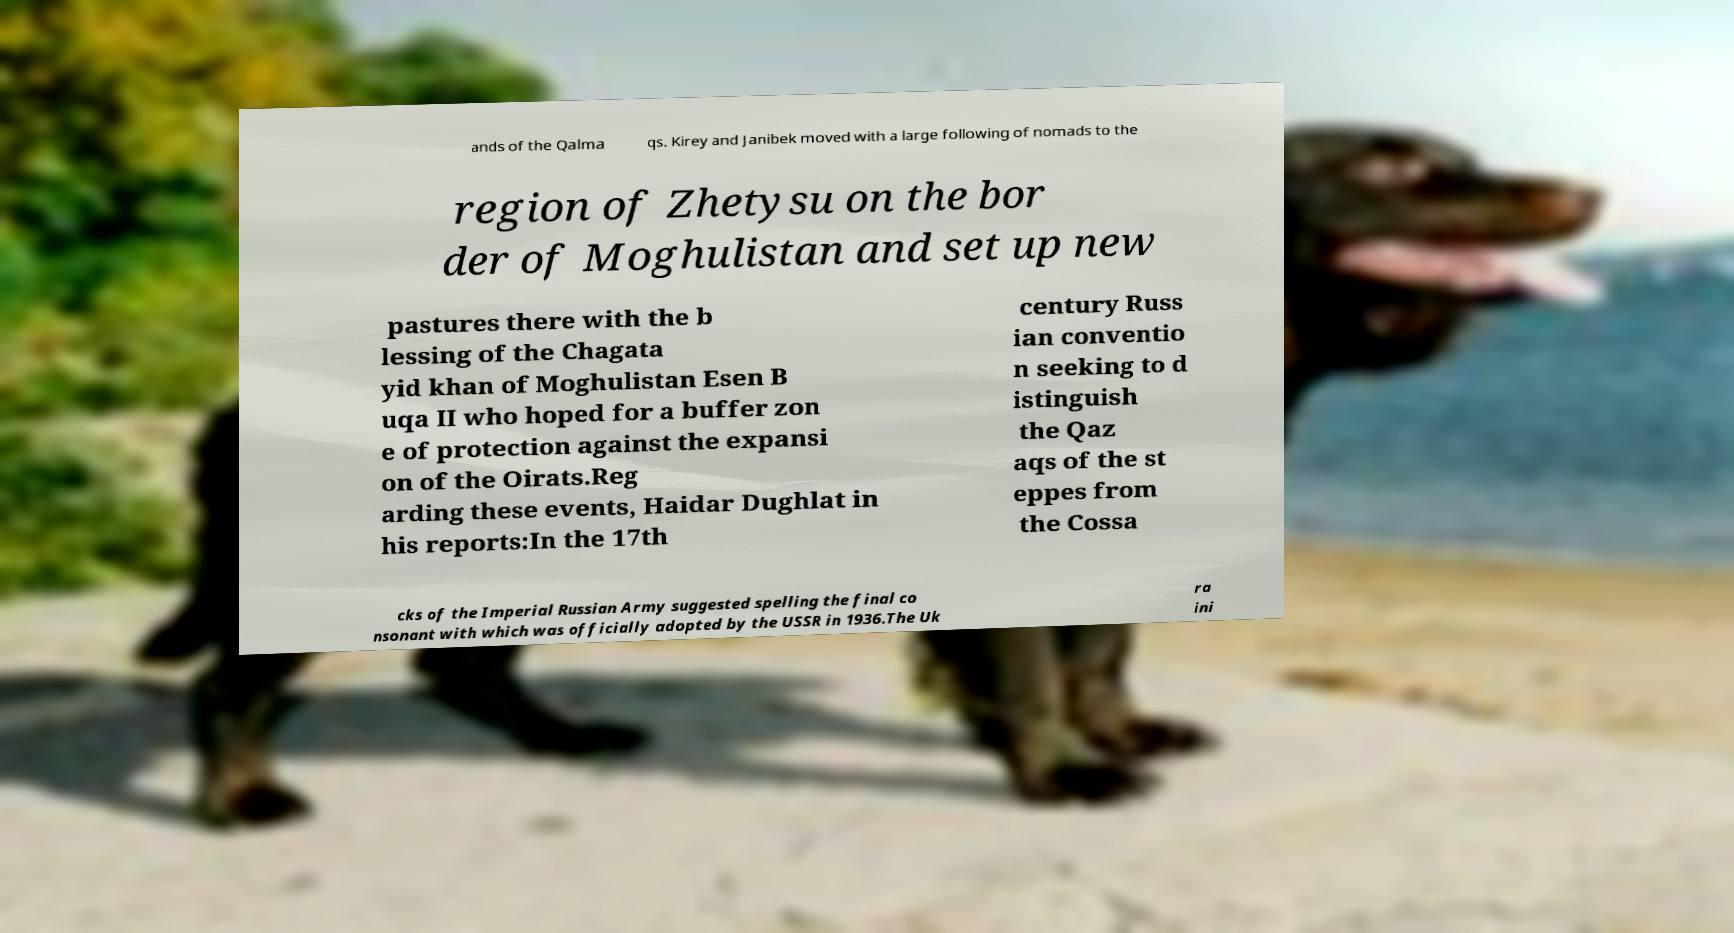Please identify and transcribe the text found in this image. ands of the Qalma qs. Kirey and Janibek moved with a large following of nomads to the region of Zhetysu on the bor der of Moghulistan and set up new pastures there with the b lessing of the Chagata yid khan of Moghulistan Esen B uqa II who hoped for a buffer zon e of protection against the expansi on of the Oirats.Reg arding these events, Haidar Dughlat in his reports:In the 17th century Russ ian conventio n seeking to d istinguish the Qaz aqs of the st eppes from the Cossa cks of the Imperial Russian Army suggested spelling the final co nsonant with which was officially adopted by the USSR in 1936.The Uk ra ini 